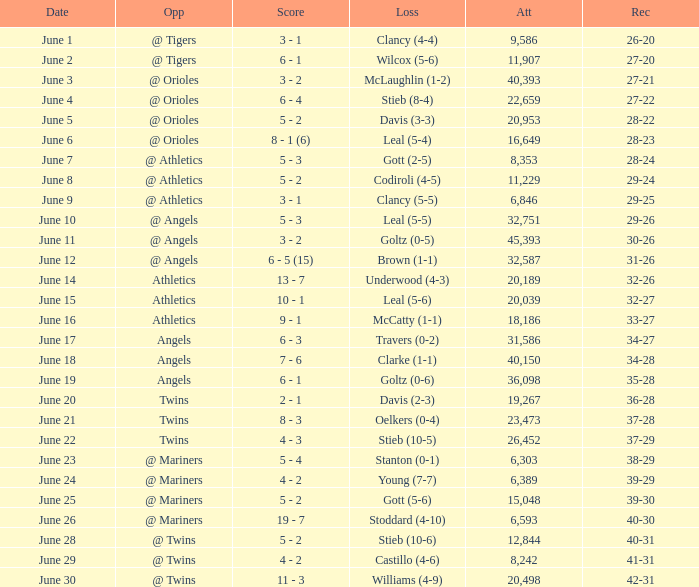What was the record for the date of June 14? 32-26. Can you parse all the data within this table? {'header': ['Date', 'Opp', 'Score', 'Loss', 'Att', 'Rec'], 'rows': [['June 1', '@ Tigers', '3 - 1', 'Clancy (4-4)', '9,586', '26-20'], ['June 2', '@ Tigers', '6 - 1', 'Wilcox (5-6)', '11,907', '27-20'], ['June 3', '@ Orioles', '3 - 2', 'McLaughlin (1-2)', '40,393', '27-21'], ['June 4', '@ Orioles', '6 - 4', 'Stieb (8-4)', '22,659', '27-22'], ['June 5', '@ Orioles', '5 - 2', 'Davis (3-3)', '20,953', '28-22'], ['June 6', '@ Orioles', '8 - 1 (6)', 'Leal (5-4)', '16,649', '28-23'], ['June 7', '@ Athletics', '5 - 3', 'Gott (2-5)', '8,353', '28-24'], ['June 8', '@ Athletics', '5 - 2', 'Codiroli (4-5)', '11,229', '29-24'], ['June 9', '@ Athletics', '3 - 1', 'Clancy (5-5)', '6,846', '29-25'], ['June 10', '@ Angels', '5 - 3', 'Leal (5-5)', '32,751', '29-26'], ['June 11', '@ Angels', '3 - 2', 'Goltz (0-5)', '45,393', '30-26'], ['June 12', '@ Angels', '6 - 5 (15)', 'Brown (1-1)', '32,587', '31-26'], ['June 14', 'Athletics', '13 - 7', 'Underwood (4-3)', '20,189', '32-26'], ['June 15', 'Athletics', '10 - 1', 'Leal (5-6)', '20,039', '32-27'], ['June 16', 'Athletics', '9 - 1', 'McCatty (1-1)', '18,186', '33-27'], ['June 17', 'Angels', '6 - 3', 'Travers (0-2)', '31,586', '34-27'], ['June 18', 'Angels', '7 - 6', 'Clarke (1-1)', '40,150', '34-28'], ['June 19', 'Angels', '6 - 1', 'Goltz (0-6)', '36,098', '35-28'], ['June 20', 'Twins', '2 - 1', 'Davis (2-3)', '19,267', '36-28'], ['June 21', 'Twins', '8 - 3', 'Oelkers (0-4)', '23,473', '37-28'], ['June 22', 'Twins', '4 - 3', 'Stieb (10-5)', '26,452', '37-29'], ['June 23', '@ Mariners', '5 - 4', 'Stanton (0-1)', '6,303', '38-29'], ['June 24', '@ Mariners', '4 - 2', 'Young (7-7)', '6,389', '39-29'], ['June 25', '@ Mariners', '5 - 2', 'Gott (5-6)', '15,048', '39-30'], ['June 26', '@ Mariners', '19 - 7', 'Stoddard (4-10)', '6,593', '40-30'], ['June 28', '@ Twins', '5 - 2', 'Stieb (10-6)', '12,844', '40-31'], ['June 29', '@ Twins', '4 - 2', 'Castillo (4-6)', '8,242', '41-31'], ['June 30', '@ Twins', '11 - 3', 'Williams (4-9)', '20,498', '42-31']]} 